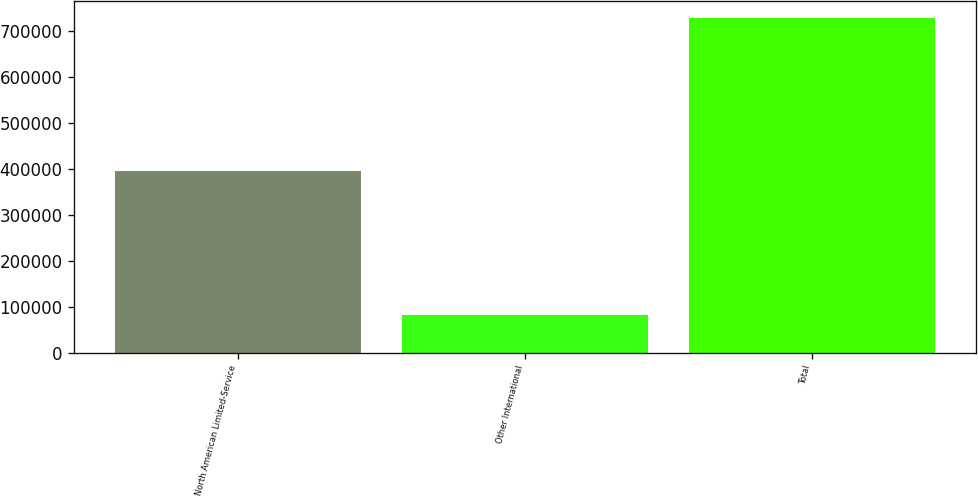Convert chart to OTSL. <chart><loc_0><loc_0><loc_500><loc_500><bar_chart><fcel>North American Limited-Service<fcel>Other International<fcel>Total<nl><fcel>395522<fcel>82243<fcel>729413<nl></chart> 